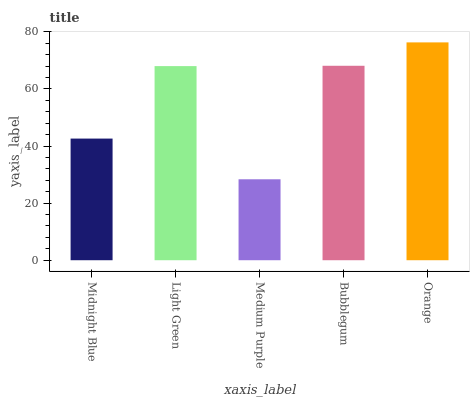Is Medium Purple the minimum?
Answer yes or no. Yes. Is Orange the maximum?
Answer yes or no. Yes. Is Light Green the minimum?
Answer yes or no. No. Is Light Green the maximum?
Answer yes or no. No. Is Light Green greater than Midnight Blue?
Answer yes or no. Yes. Is Midnight Blue less than Light Green?
Answer yes or no. Yes. Is Midnight Blue greater than Light Green?
Answer yes or no. No. Is Light Green less than Midnight Blue?
Answer yes or no. No. Is Light Green the high median?
Answer yes or no. Yes. Is Light Green the low median?
Answer yes or no. Yes. Is Midnight Blue the high median?
Answer yes or no. No. Is Orange the low median?
Answer yes or no. No. 